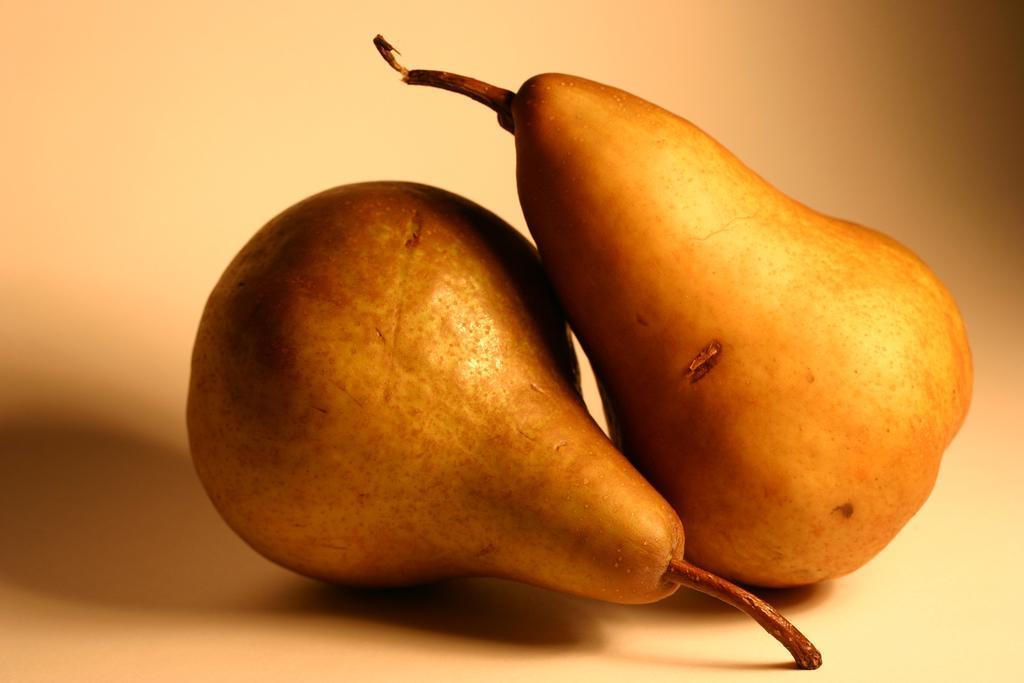Can you describe this image briefly? In the center of the picture there are pears fruits on a white surface. 